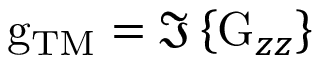<formula> <loc_0><loc_0><loc_500><loc_500>g _ { T M } = \Im \left \{ G _ { z z } \right \}</formula> 